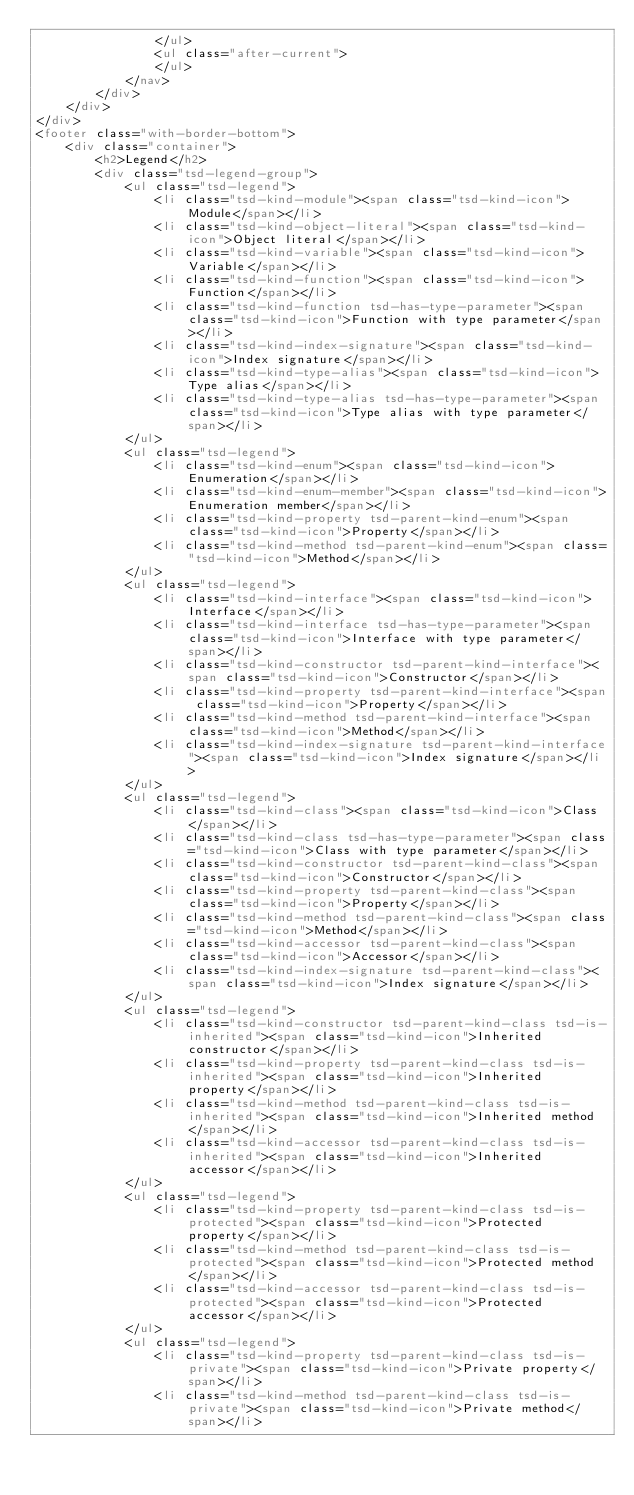<code> <loc_0><loc_0><loc_500><loc_500><_HTML_>				</ul>
				<ul class="after-current">
				</ul>
			</nav>
		</div>
	</div>
</div>
<footer class="with-border-bottom">
	<div class="container">
		<h2>Legend</h2>
		<div class="tsd-legend-group">
			<ul class="tsd-legend">
				<li class="tsd-kind-module"><span class="tsd-kind-icon">Module</span></li>
				<li class="tsd-kind-object-literal"><span class="tsd-kind-icon">Object literal</span></li>
				<li class="tsd-kind-variable"><span class="tsd-kind-icon">Variable</span></li>
				<li class="tsd-kind-function"><span class="tsd-kind-icon">Function</span></li>
				<li class="tsd-kind-function tsd-has-type-parameter"><span class="tsd-kind-icon">Function with type parameter</span></li>
				<li class="tsd-kind-index-signature"><span class="tsd-kind-icon">Index signature</span></li>
				<li class="tsd-kind-type-alias"><span class="tsd-kind-icon">Type alias</span></li>
				<li class="tsd-kind-type-alias tsd-has-type-parameter"><span class="tsd-kind-icon">Type alias with type parameter</span></li>
			</ul>
			<ul class="tsd-legend">
				<li class="tsd-kind-enum"><span class="tsd-kind-icon">Enumeration</span></li>
				<li class="tsd-kind-enum-member"><span class="tsd-kind-icon">Enumeration member</span></li>
				<li class="tsd-kind-property tsd-parent-kind-enum"><span class="tsd-kind-icon">Property</span></li>
				<li class="tsd-kind-method tsd-parent-kind-enum"><span class="tsd-kind-icon">Method</span></li>
			</ul>
			<ul class="tsd-legend">
				<li class="tsd-kind-interface"><span class="tsd-kind-icon">Interface</span></li>
				<li class="tsd-kind-interface tsd-has-type-parameter"><span class="tsd-kind-icon">Interface with type parameter</span></li>
				<li class="tsd-kind-constructor tsd-parent-kind-interface"><span class="tsd-kind-icon">Constructor</span></li>
				<li class="tsd-kind-property tsd-parent-kind-interface"><span class="tsd-kind-icon">Property</span></li>
				<li class="tsd-kind-method tsd-parent-kind-interface"><span class="tsd-kind-icon">Method</span></li>
				<li class="tsd-kind-index-signature tsd-parent-kind-interface"><span class="tsd-kind-icon">Index signature</span></li>
			</ul>
			<ul class="tsd-legend">
				<li class="tsd-kind-class"><span class="tsd-kind-icon">Class</span></li>
				<li class="tsd-kind-class tsd-has-type-parameter"><span class="tsd-kind-icon">Class with type parameter</span></li>
				<li class="tsd-kind-constructor tsd-parent-kind-class"><span class="tsd-kind-icon">Constructor</span></li>
				<li class="tsd-kind-property tsd-parent-kind-class"><span class="tsd-kind-icon">Property</span></li>
				<li class="tsd-kind-method tsd-parent-kind-class"><span class="tsd-kind-icon">Method</span></li>
				<li class="tsd-kind-accessor tsd-parent-kind-class"><span class="tsd-kind-icon">Accessor</span></li>
				<li class="tsd-kind-index-signature tsd-parent-kind-class"><span class="tsd-kind-icon">Index signature</span></li>
			</ul>
			<ul class="tsd-legend">
				<li class="tsd-kind-constructor tsd-parent-kind-class tsd-is-inherited"><span class="tsd-kind-icon">Inherited constructor</span></li>
				<li class="tsd-kind-property tsd-parent-kind-class tsd-is-inherited"><span class="tsd-kind-icon">Inherited property</span></li>
				<li class="tsd-kind-method tsd-parent-kind-class tsd-is-inherited"><span class="tsd-kind-icon">Inherited method</span></li>
				<li class="tsd-kind-accessor tsd-parent-kind-class tsd-is-inherited"><span class="tsd-kind-icon">Inherited accessor</span></li>
			</ul>
			<ul class="tsd-legend">
				<li class="tsd-kind-property tsd-parent-kind-class tsd-is-protected"><span class="tsd-kind-icon">Protected property</span></li>
				<li class="tsd-kind-method tsd-parent-kind-class tsd-is-protected"><span class="tsd-kind-icon">Protected method</span></li>
				<li class="tsd-kind-accessor tsd-parent-kind-class tsd-is-protected"><span class="tsd-kind-icon">Protected accessor</span></li>
			</ul>
			<ul class="tsd-legend">
				<li class="tsd-kind-property tsd-parent-kind-class tsd-is-private"><span class="tsd-kind-icon">Private property</span></li>
				<li class="tsd-kind-method tsd-parent-kind-class tsd-is-private"><span class="tsd-kind-icon">Private method</span></li></code> 